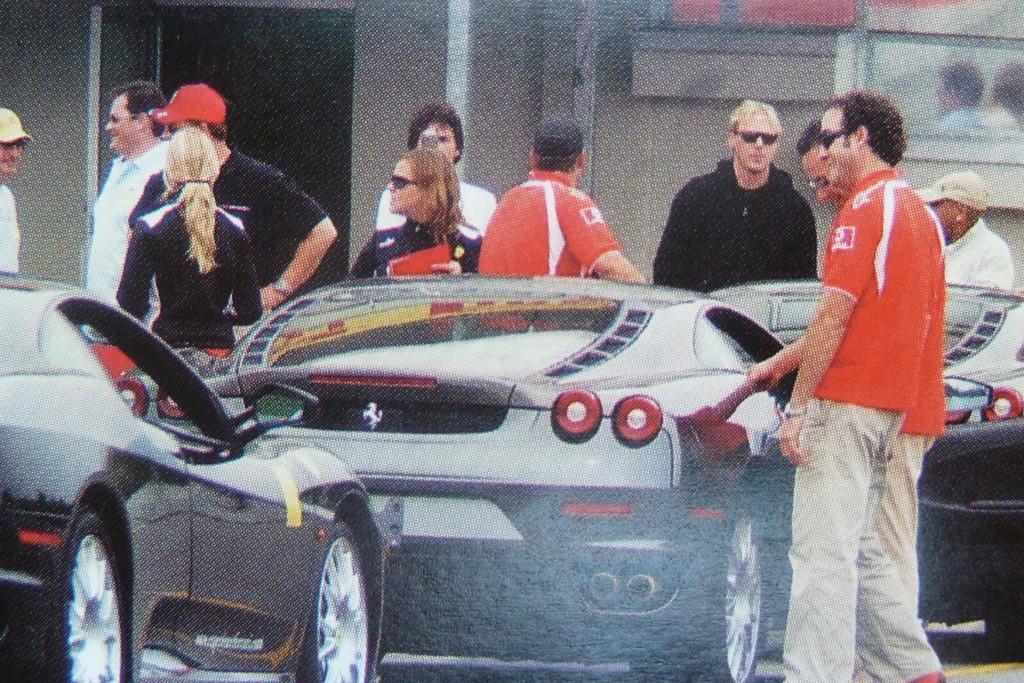What can be seen in the image? There are cars and a group of people standing on the ground in the image. What are some of the people wearing? Some of the people are wearing goggles and caps. What can be seen in the background of the image? There is a wall and glass in the background of the image. How many dimes can be seen on the ground in the image? There are no dimes visible on the ground in the image. What type of lipstick is the person wearing in the image? There is no lipstick or person wearing lipstick present in the image. 